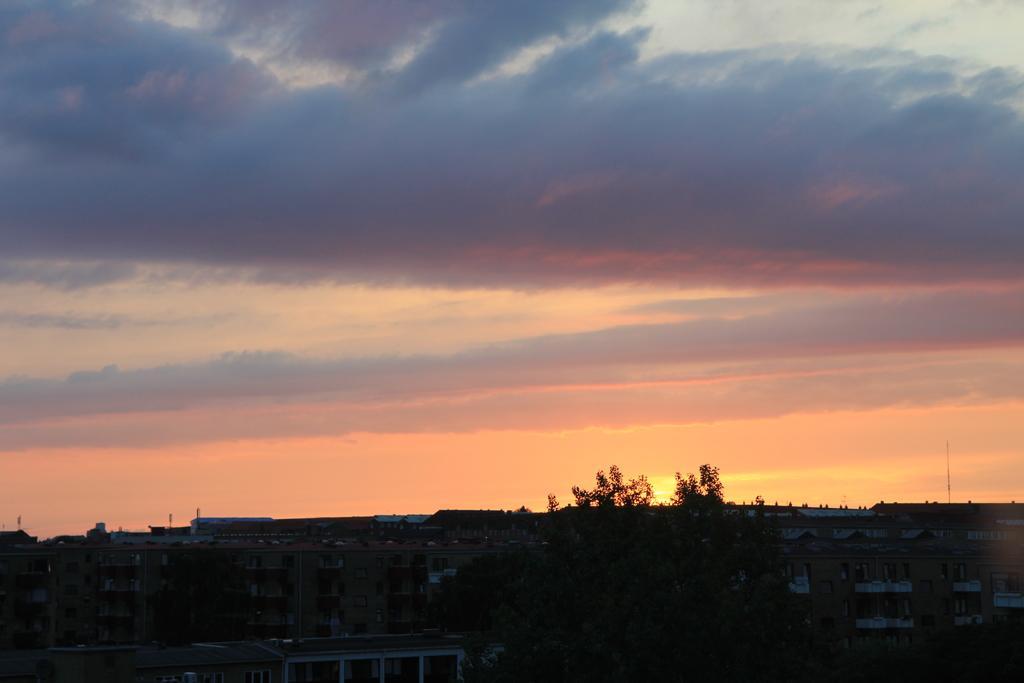How would you summarize this image in a sentence or two? In this picture we can see buildings and a tree at the bottom, there is the sky at the top of the picture. 